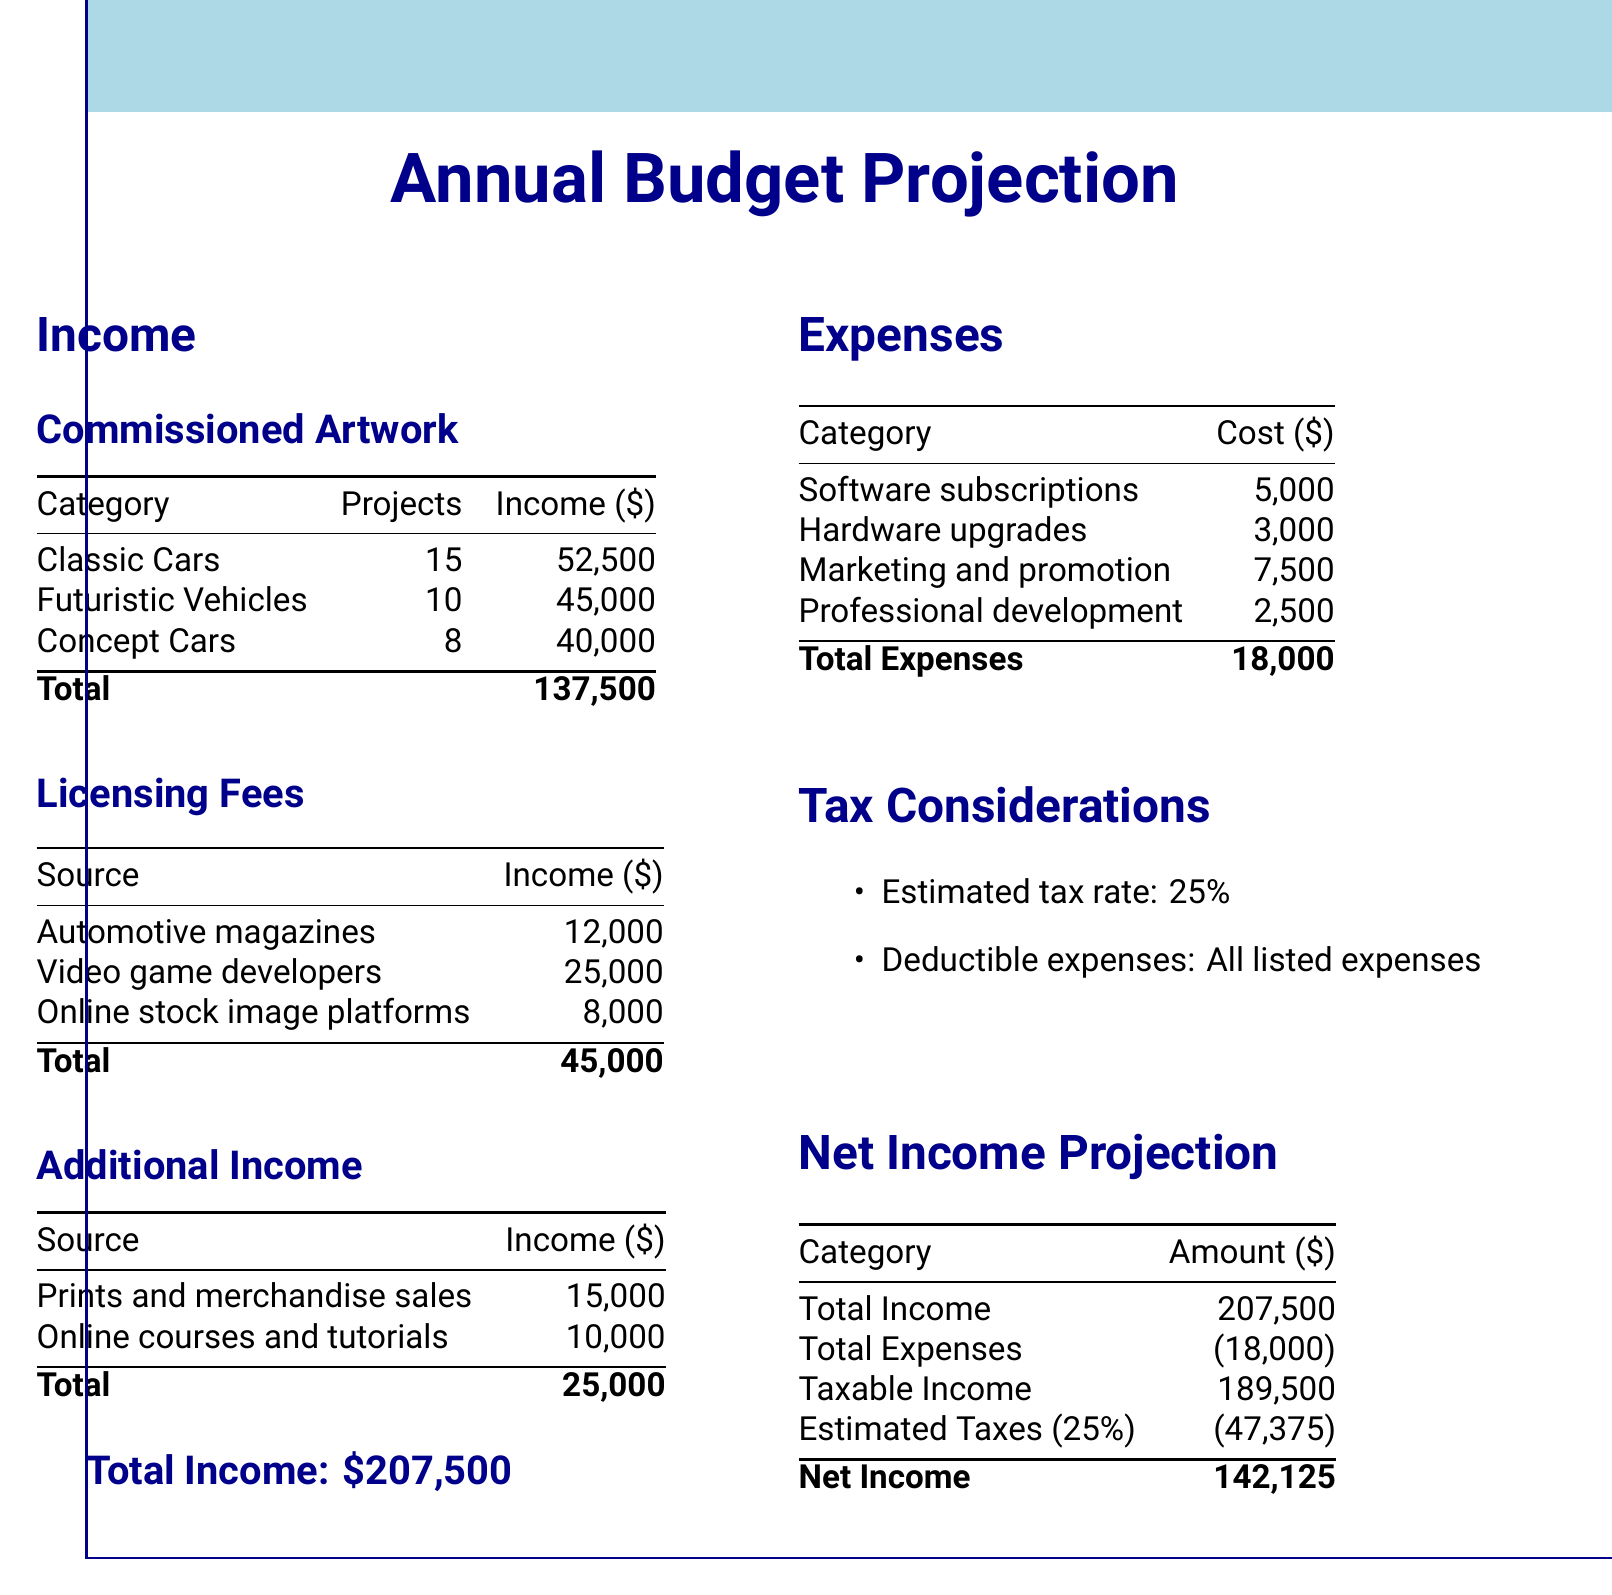what is the total income projected? The total income is the sum of all income sources listed in the document, which amounts to $137,500 from commissioned artwork plus $45,000 from licensing fees plus $25,000 from additional income.
Answer: $207,500 how many commissioned projects are there for classic cars? The document specifies that there are 15 projects for classic cars under the commissioned artwork section.
Answer: 15 what is the income from video game developers? The income from video game developers is listed in the licensing fees section of the document.
Answer: $25,000 what category has the highest expense? To find the category with the highest expense, we compare all listed expenses: software subscriptions, hardware upgrades, marketing and promotion, and professional development. Marketing and promotion has the highest cost.
Answer: Marketing and promotion what is the estimated tax rate mentioned in the document? The document lists the estimated tax rate under the tax considerations section, which is used to calculate estimated taxes.
Answer: 25% 